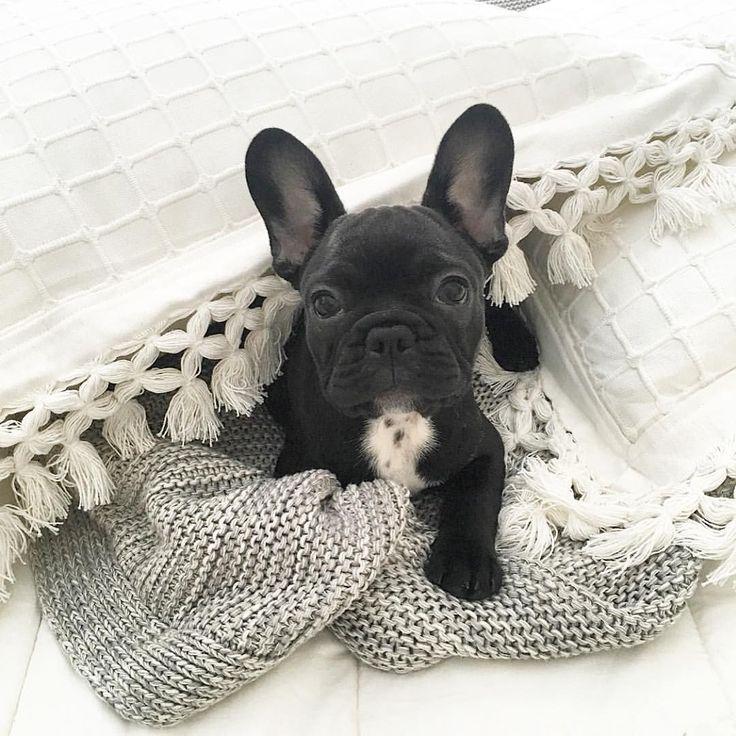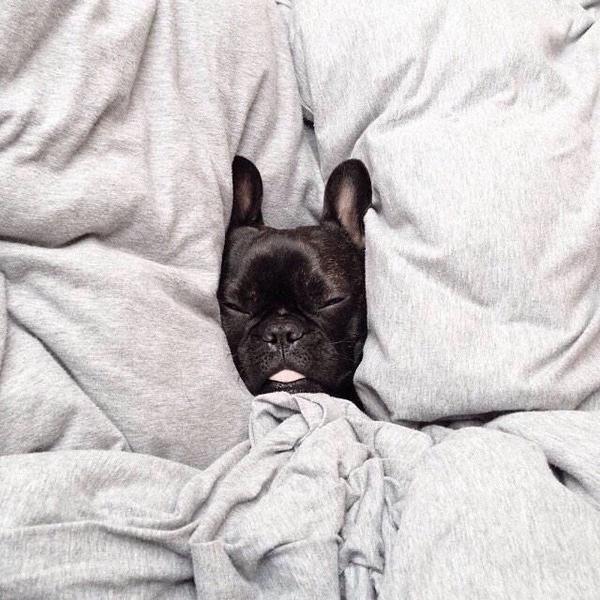The first image is the image on the left, the second image is the image on the right. Examine the images to the left and right. Is the description "There are two black French Bulldogs." accurate? Answer yes or no. Yes. 